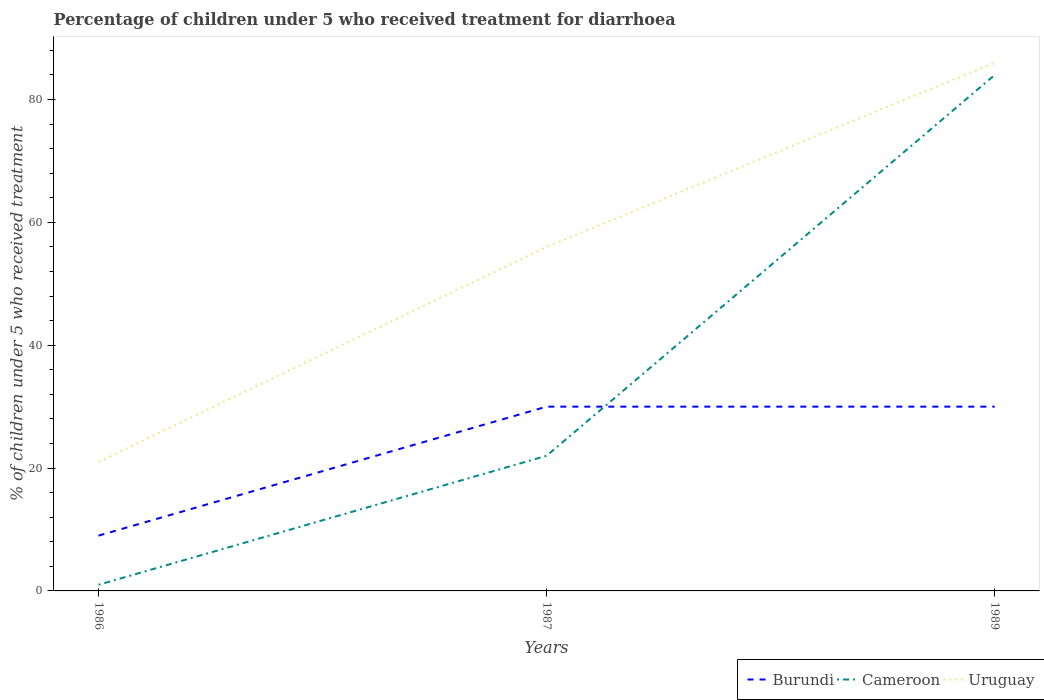How many different coloured lines are there?
Keep it short and to the point. 3. Does the line corresponding to Burundi intersect with the line corresponding to Uruguay?
Offer a very short reply. No. In which year was the percentage of children who received treatment for diarrhoea  in Cameroon maximum?
Provide a short and direct response. 1986. What is the difference between the highest and the lowest percentage of children who received treatment for diarrhoea  in Burundi?
Offer a terse response. 2. How many lines are there?
Keep it short and to the point. 3. Where does the legend appear in the graph?
Your response must be concise. Bottom right. How many legend labels are there?
Provide a succinct answer. 3. How are the legend labels stacked?
Keep it short and to the point. Horizontal. What is the title of the graph?
Your answer should be very brief. Percentage of children under 5 who received treatment for diarrhoea. What is the label or title of the X-axis?
Give a very brief answer. Years. What is the label or title of the Y-axis?
Provide a succinct answer. % of children under 5 who received treatment. What is the % of children under 5 who received treatment of Burundi in 1986?
Keep it short and to the point. 9. What is the % of children under 5 who received treatment in Uruguay in 1986?
Provide a short and direct response. 21. What is the % of children under 5 who received treatment in Burundi in 1987?
Your answer should be very brief. 30. Across all years, what is the maximum % of children under 5 who received treatment of Burundi?
Your answer should be compact. 30. Across all years, what is the maximum % of children under 5 who received treatment in Cameroon?
Your answer should be compact. 84. Across all years, what is the minimum % of children under 5 who received treatment of Cameroon?
Your answer should be compact. 1. What is the total % of children under 5 who received treatment in Cameroon in the graph?
Offer a very short reply. 107. What is the total % of children under 5 who received treatment of Uruguay in the graph?
Provide a short and direct response. 163. What is the difference between the % of children under 5 who received treatment in Burundi in 1986 and that in 1987?
Make the answer very short. -21. What is the difference between the % of children under 5 who received treatment in Uruguay in 1986 and that in 1987?
Ensure brevity in your answer.  -35. What is the difference between the % of children under 5 who received treatment of Cameroon in 1986 and that in 1989?
Offer a terse response. -83. What is the difference between the % of children under 5 who received treatment of Uruguay in 1986 and that in 1989?
Provide a succinct answer. -65. What is the difference between the % of children under 5 who received treatment in Burundi in 1987 and that in 1989?
Your answer should be compact. 0. What is the difference between the % of children under 5 who received treatment of Cameroon in 1987 and that in 1989?
Provide a succinct answer. -62. What is the difference between the % of children under 5 who received treatment in Uruguay in 1987 and that in 1989?
Make the answer very short. -30. What is the difference between the % of children under 5 who received treatment of Burundi in 1986 and the % of children under 5 who received treatment of Uruguay in 1987?
Give a very brief answer. -47. What is the difference between the % of children under 5 who received treatment in Cameroon in 1986 and the % of children under 5 who received treatment in Uruguay in 1987?
Your response must be concise. -55. What is the difference between the % of children under 5 who received treatment in Burundi in 1986 and the % of children under 5 who received treatment in Cameroon in 1989?
Offer a terse response. -75. What is the difference between the % of children under 5 who received treatment of Burundi in 1986 and the % of children under 5 who received treatment of Uruguay in 1989?
Your response must be concise. -77. What is the difference between the % of children under 5 who received treatment of Cameroon in 1986 and the % of children under 5 who received treatment of Uruguay in 1989?
Offer a terse response. -85. What is the difference between the % of children under 5 who received treatment in Burundi in 1987 and the % of children under 5 who received treatment in Cameroon in 1989?
Ensure brevity in your answer.  -54. What is the difference between the % of children under 5 who received treatment of Burundi in 1987 and the % of children under 5 who received treatment of Uruguay in 1989?
Make the answer very short. -56. What is the difference between the % of children under 5 who received treatment in Cameroon in 1987 and the % of children under 5 who received treatment in Uruguay in 1989?
Offer a terse response. -64. What is the average % of children under 5 who received treatment in Cameroon per year?
Give a very brief answer. 35.67. What is the average % of children under 5 who received treatment in Uruguay per year?
Your answer should be very brief. 54.33. In the year 1987, what is the difference between the % of children under 5 who received treatment of Burundi and % of children under 5 who received treatment of Cameroon?
Provide a short and direct response. 8. In the year 1987, what is the difference between the % of children under 5 who received treatment of Burundi and % of children under 5 who received treatment of Uruguay?
Give a very brief answer. -26. In the year 1987, what is the difference between the % of children under 5 who received treatment in Cameroon and % of children under 5 who received treatment in Uruguay?
Your response must be concise. -34. In the year 1989, what is the difference between the % of children under 5 who received treatment of Burundi and % of children under 5 who received treatment of Cameroon?
Your answer should be compact. -54. In the year 1989, what is the difference between the % of children under 5 who received treatment in Burundi and % of children under 5 who received treatment in Uruguay?
Make the answer very short. -56. What is the ratio of the % of children under 5 who received treatment of Burundi in 1986 to that in 1987?
Your answer should be compact. 0.3. What is the ratio of the % of children under 5 who received treatment of Cameroon in 1986 to that in 1987?
Provide a succinct answer. 0.05. What is the ratio of the % of children under 5 who received treatment of Uruguay in 1986 to that in 1987?
Provide a succinct answer. 0.38. What is the ratio of the % of children under 5 who received treatment of Cameroon in 1986 to that in 1989?
Your answer should be compact. 0.01. What is the ratio of the % of children under 5 who received treatment in Uruguay in 1986 to that in 1989?
Offer a terse response. 0.24. What is the ratio of the % of children under 5 who received treatment of Burundi in 1987 to that in 1989?
Your response must be concise. 1. What is the ratio of the % of children under 5 who received treatment of Cameroon in 1987 to that in 1989?
Your response must be concise. 0.26. What is the ratio of the % of children under 5 who received treatment of Uruguay in 1987 to that in 1989?
Offer a very short reply. 0.65. What is the difference between the highest and the second highest % of children under 5 who received treatment in Burundi?
Offer a very short reply. 0. What is the difference between the highest and the second highest % of children under 5 who received treatment of Cameroon?
Offer a very short reply. 62. What is the difference between the highest and the second highest % of children under 5 who received treatment in Uruguay?
Your answer should be compact. 30. What is the difference between the highest and the lowest % of children under 5 who received treatment in Burundi?
Ensure brevity in your answer.  21. What is the difference between the highest and the lowest % of children under 5 who received treatment in Cameroon?
Provide a short and direct response. 83. 